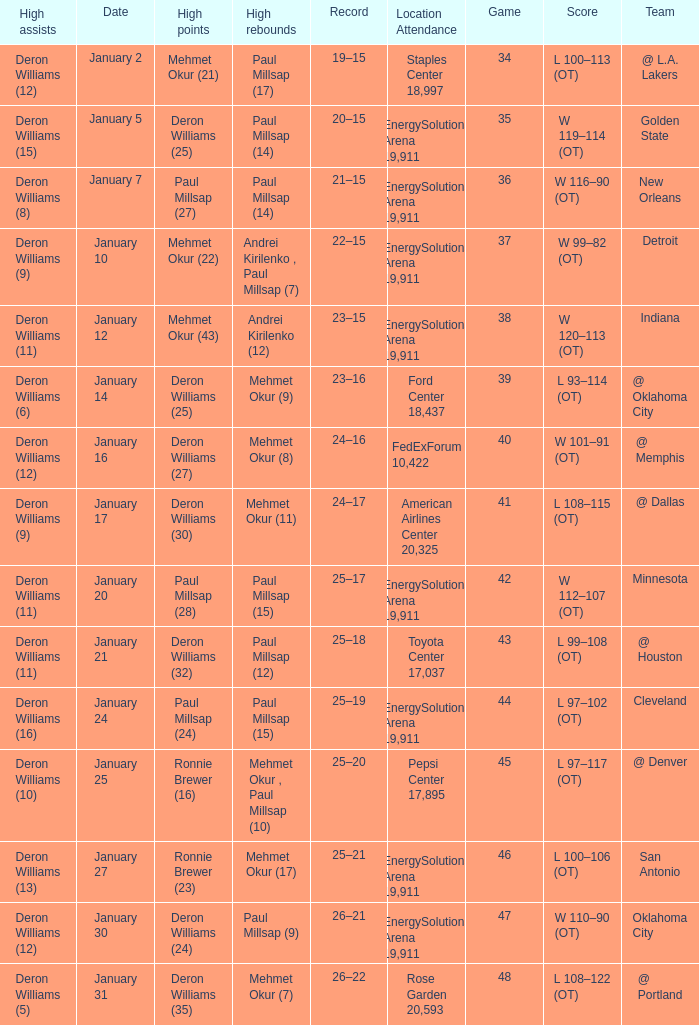Who had the high rebounds of the game that Deron Williams (5) had the high assists? Mehmet Okur (7). 